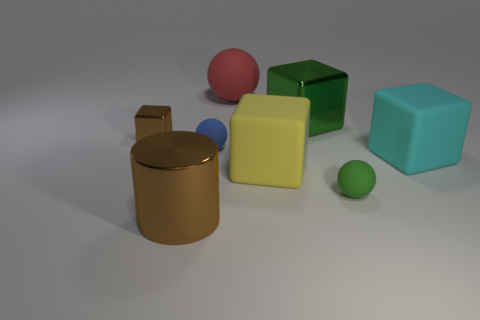Subtract all big metal blocks. How many blocks are left? 3 Add 1 purple matte cubes. How many objects exist? 9 Subtract all gray cubes. Subtract all red cylinders. How many cubes are left? 4 Subtract all balls. How many objects are left? 5 Subtract all gray shiny objects. Subtract all large rubber spheres. How many objects are left? 7 Add 6 cyan blocks. How many cyan blocks are left? 7 Add 1 brown things. How many brown things exist? 3 Subtract 1 brown cylinders. How many objects are left? 7 